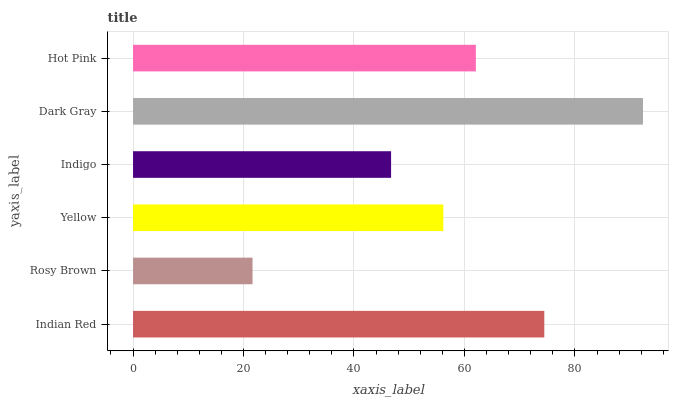Is Rosy Brown the minimum?
Answer yes or no. Yes. Is Dark Gray the maximum?
Answer yes or no. Yes. Is Yellow the minimum?
Answer yes or no. No. Is Yellow the maximum?
Answer yes or no. No. Is Yellow greater than Rosy Brown?
Answer yes or no. Yes. Is Rosy Brown less than Yellow?
Answer yes or no. Yes. Is Rosy Brown greater than Yellow?
Answer yes or no. No. Is Yellow less than Rosy Brown?
Answer yes or no. No. Is Hot Pink the high median?
Answer yes or no. Yes. Is Yellow the low median?
Answer yes or no. Yes. Is Indian Red the high median?
Answer yes or no. No. Is Indian Red the low median?
Answer yes or no. No. 